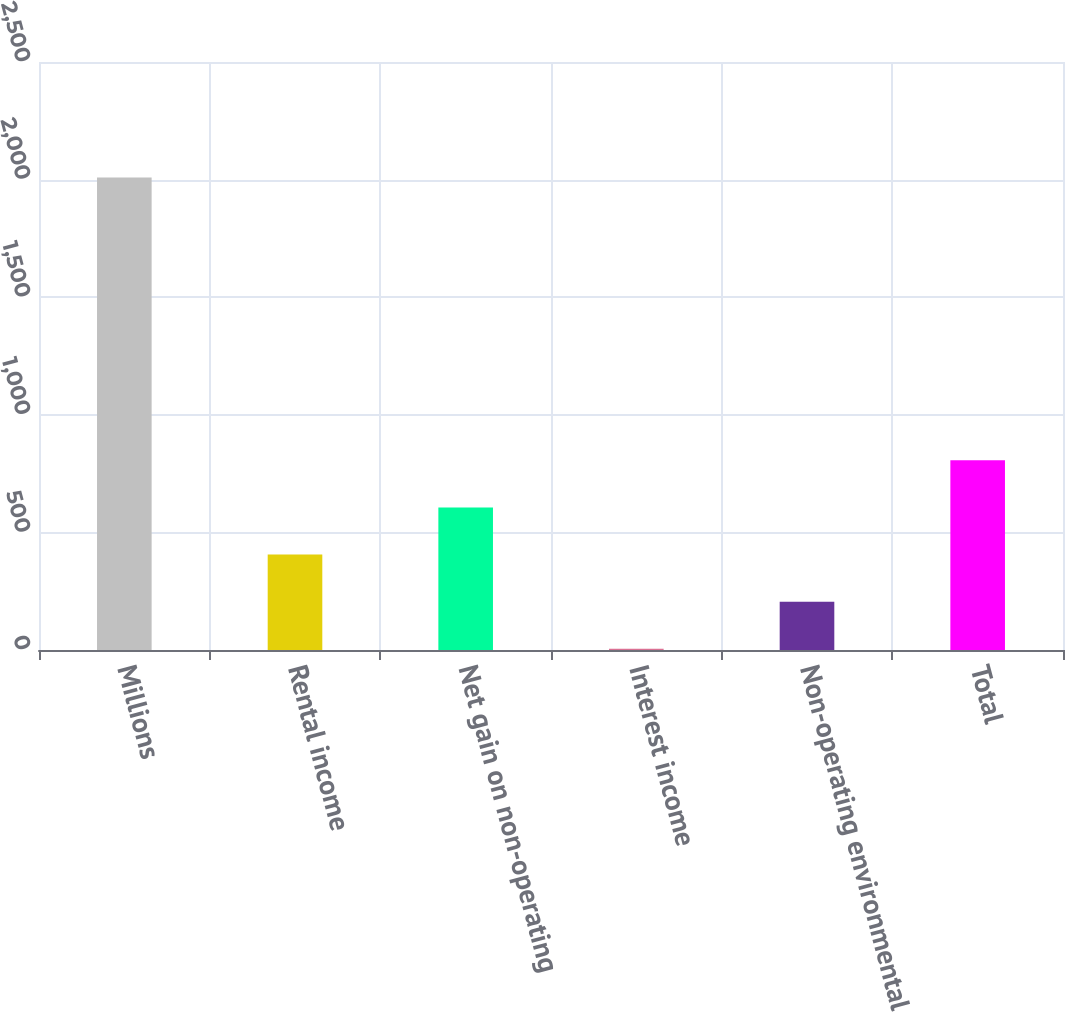<chart> <loc_0><loc_0><loc_500><loc_500><bar_chart><fcel>Millions<fcel>Rental income<fcel>Net gain on non-operating<fcel>Interest income<fcel>Non-operating environmental<fcel>Total<nl><fcel>2009<fcel>405.8<fcel>606.2<fcel>5<fcel>205.4<fcel>806.6<nl></chart> 